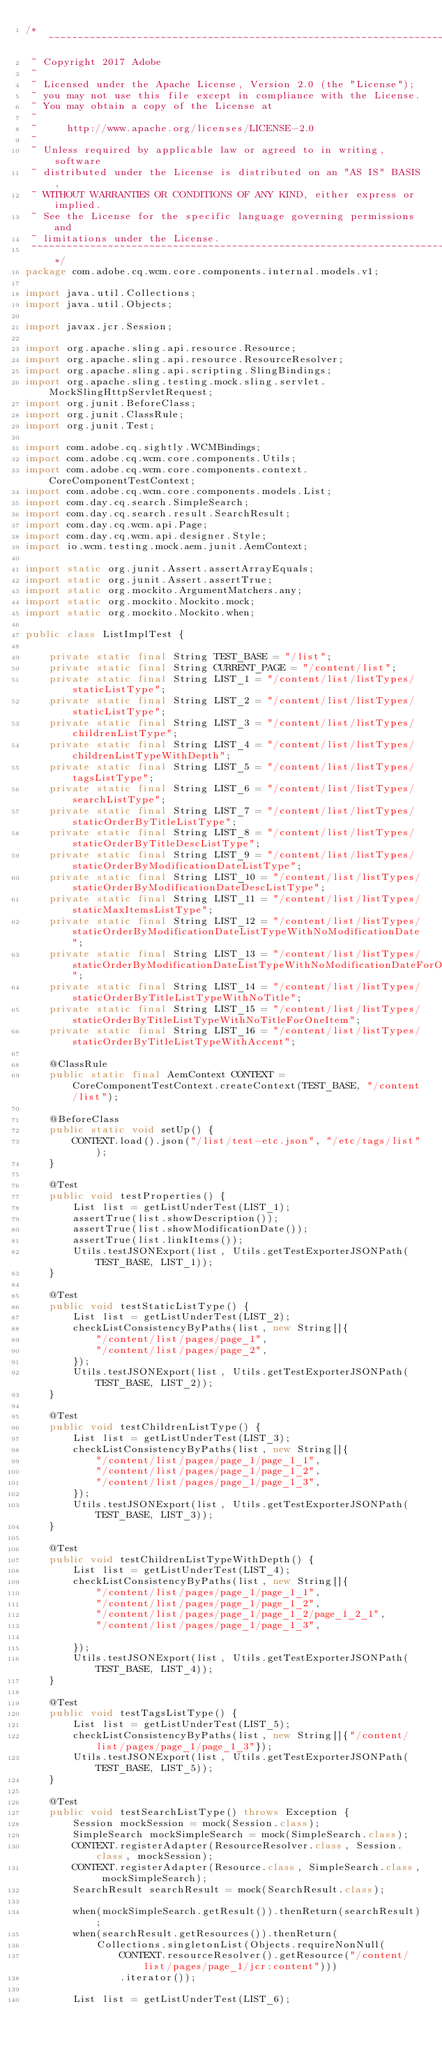<code> <loc_0><loc_0><loc_500><loc_500><_Java_>/*~~~~~~~~~~~~~~~~~~~~~~~~~~~~~~~~~~~~~~~~~~~~~~~~~~~~~~~~~~~~~~~~~~~~~~~~~~~~~~
 ~ Copyright 2017 Adobe
 ~
 ~ Licensed under the Apache License, Version 2.0 (the "License");
 ~ you may not use this file except in compliance with the License.
 ~ You may obtain a copy of the License at
 ~
 ~     http://www.apache.org/licenses/LICENSE-2.0
 ~
 ~ Unless required by applicable law or agreed to in writing, software
 ~ distributed under the License is distributed on an "AS IS" BASIS,
 ~ WITHOUT WARRANTIES OR CONDITIONS OF ANY KIND, either express or implied.
 ~ See the License for the specific language governing permissions and
 ~ limitations under the License.
 ~~~~~~~~~~~~~~~~~~~~~~~~~~~~~~~~~~~~~~~~~~~~~~~~~~~~~~~~~~~~~~~~~~~~~~~~~~~~~*/
package com.adobe.cq.wcm.core.components.internal.models.v1;

import java.util.Collections;
import java.util.Objects;

import javax.jcr.Session;

import org.apache.sling.api.resource.Resource;
import org.apache.sling.api.resource.ResourceResolver;
import org.apache.sling.api.scripting.SlingBindings;
import org.apache.sling.testing.mock.sling.servlet.MockSlingHttpServletRequest;
import org.junit.BeforeClass;
import org.junit.ClassRule;
import org.junit.Test;

import com.adobe.cq.sightly.WCMBindings;
import com.adobe.cq.wcm.core.components.Utils;
import com.adobe.cq.wcm.core.components.context.CoreComponentTestContext;
import com.adobe.cq.wcm.core.components.models.List;
import com.day.cq.search.SimpleSearch;
import com.day.cq.search.result.SearchResult;
import com.day.cq.wcm.api.Page;
import com.day.cq.wcm.api.designer.Style;
import io.wcm.testing.mock.aem.junit.AemContext;

import static org.junit.Assert.assertArrayEquals;
import static org.junit.Assert.assertTrue;
import static org.mockito.ArgumentMatchers.any;
import static org.mockito.Mockito.mock;
import static org.mockito.Mockito.when;

public class ListImplTest {

    private static final String TEST_BASE = "/list";
    private static final String CURRENT_PAGE = "/content/list";
    private static final String LIST_1 = "/content/list/listTypes/staticListType";
    private static final String LIST_2 = "/content/list/listTypes/staticListType";
    private static final String LIST_3 = "/content/list/listTypes/childrenListType";
    private static final String LIST_4 = "/content/list/listTypes/childrenListTypeWithDepth";
    private static final String LIST_5 = "/content/list/listTypes/tagsListType";
    private static final String LIST_6 = "/content/list/listTypes/searchListType";
    private static final String LIST_7 = "/content/list/listTypes/staticOrderByTitleListType";
    private static final String LIST_8 = "/content/list/listTypes/staticOrderByTitleDescListType";
    private static final String LIST_9 = "/content/list/listTypes/staticOrderByModificationDateListType";
    private static final String LIST_10 = "/content/list/listTypes/staticOrderByModificationDateDescListType";
    private static final String LIST_11 = "/content/list/listTypes/staticMaxItemsListType";
    private static final String LIST_12 = "/content/list/listTypes/staticOrderByModificationDateListTypeWithNoModificationDate";
    private static final String LIST_13 = "/content/list/listTypes/staticOrderByModificationDateListTypeWithNoModificationDateForOneItem";
    private static final String LIST_14 = "/content/list/listTypes/staticOrderByTitleListTypeWithNoTitle";
    private static final String LIST_15 = "/content/list/listTypes/staticOrderByTitleListTypeWithNoTitleForOneItem";
    private static final String LIST_16 = "/content/list/listTypes/staticOrderByTitleListTypeWithAccent";

    @ClassRule
    public static final AemContext CONTEXT = CoreComponentTestContext.createContext(TEST_BASE, "/content/list");

    @BeforeClass
    public static void setUp() {
        CONTEXT.load().json("/list/test-etc.json", "/etc/tags/list");
    }

    @Test
    public void testProperties() {
        List list = getListUnderTest(LIST_1);
        assertTrue(list.showDescription());
        assertTrue(list.showModificationDate());
        assertTrue(list.linkItems());
        Utils.testJSONExport(list, Utils.getTestExporterJSONPath(TEST_BASE, LIST_1));
    }

    @Test
    public void testStaticListType() {
        List list = getListUnderTest(LIST_2);
        checkListConsistencyByPaths(list, new String[]{
            "/content/list/pages/page_1",
            "/content/list/pages/page_2",
        });
        Utils.testJSONExport(list, Utils.getTestExporterJSONPath(TEST_BASE, LIST_2));
    }

    @Test
    public void testChildrenListType() {
        List list = getListUnderTest(LIST_3);
        checkListConsistencyByPaths(list, new String[]{
            "/content/list/pages/page_1/page_1_1",
            "/content/list/pages/page_1/page_1_2",
            "/content/list/pages/page_1/page_1_3",
        });
        Utils.testJSONExport(list, Utils.getTestExporterJSONPath(TEST_BASE, LIST_3));
    }

    @Test
    public void testChildrenListTypeWithDepth() {
        List list = getListUnderTest(LIST_4);
        checkListConsistencyByPaths(list, new String[]{
            "/content/list/pages/page_1/page_1_1",
            "/content/list/pages/page_1/page_1_2",
            "/content/list/pages/page_1/page_1_2/page_1_2_1",
            "/content/list/pages/page_1/page_1_3",

        });
        Utils.testJSONExport(list, Utils.getTestExporterJSONPath(TEST_BASE, LIST_4));
    }

    @Test
    public void testTagsListType() {
        List list = getListUnderTest(LIST_5);
        checkListConsistencyByPaths(list, new String[]{"/content/list/pages/page_1/page_1_3"});
        Utils.testJSONExport(list, Utils.getTestExporterJSONPath(TEST_BASE, LIST_5));
    }

    @Test
    public void testSearchListType() throws Exception {
        Session mockSession = mock(Session.class);
        SimpleSearch mockSimpleSearch = mock(SimpleSearch.class);
        CONTEXT.registerAdapter(ResourceResolver.class, Session.class, mockSession);
        CONTEXT.registerAdapter(Resource.class, SimpleSearch.class, mockSimpleSearch);
        SearchResult searchResult = mock(SearchResult.class);

        when(mockSimpleSearch.getResult()).thenReturn(searchResult);
        when(searchResult.getResources()).thenReturn(
            Collections.singletonList(Objects.requireNonNull(
                CONTEXT.resourceResolver().getResource("/content/list/pages/page_1/jcr:content")))
                .iterator());

        List list = getListUnderTest(LIST_6);</code> 